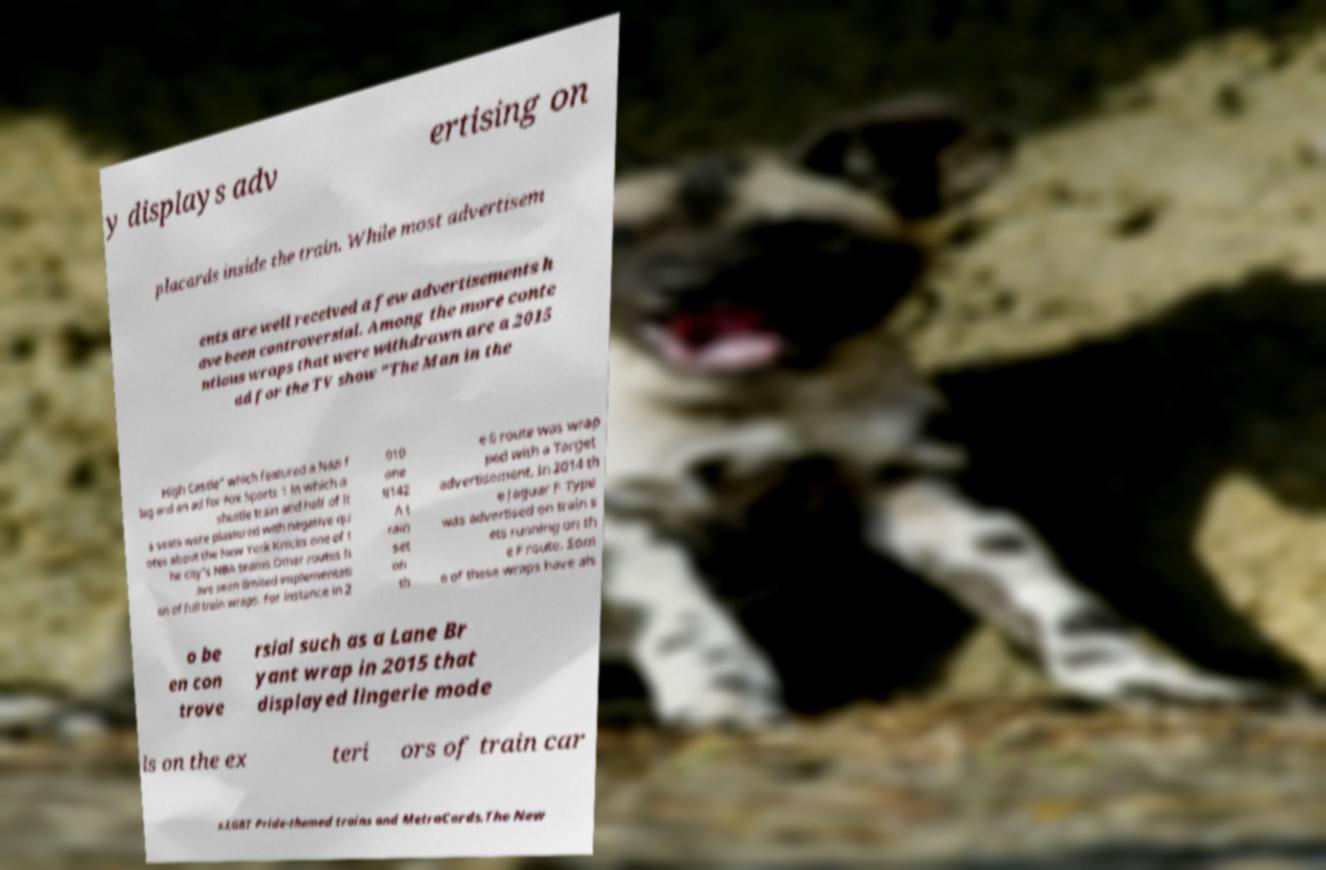Please read and relay the text visible in this image. What does it say? y displays adv ertising on placards inside the train. While most advertisem ents are well received a few advertisements h ave been controversial. Among the more conte ntious wraps that were withdrawn are a 2015 ad for the TV show "The Man in the High Castle" which featured a Nazi f lag and an ad for Fox Sports 1 in which a shuttle train and half of it s seats were plastered with negative qu otes about the New York Knicks one of t he city's NBA teams.Other routes h ave seen limited implementati on of full train wraps. For instance in 2 010 one R142 A t rain set on th e 6 route was wrap ped with a Target advertisement. In 2014 th e Jaguar F-Type was advertised on train s ets running on th e F route. Som e of these wraps have als o be en con trove rsial such as a Lane Br yant wrap in 2015 that displayed lingerie mode ls on the ex teri ors of train car s.LGBT Pride-themed trains and MetroCards.The New 